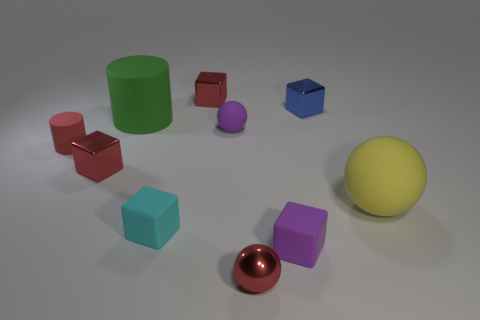There is a purple thing that is in front of the big rubber sphere; what is its size? The purple object, which appears to be a small sphere, is significantly smaller than the large yellow rubber sphere in the background. It seems to be comparable in size to the other small objects surrounding it. 